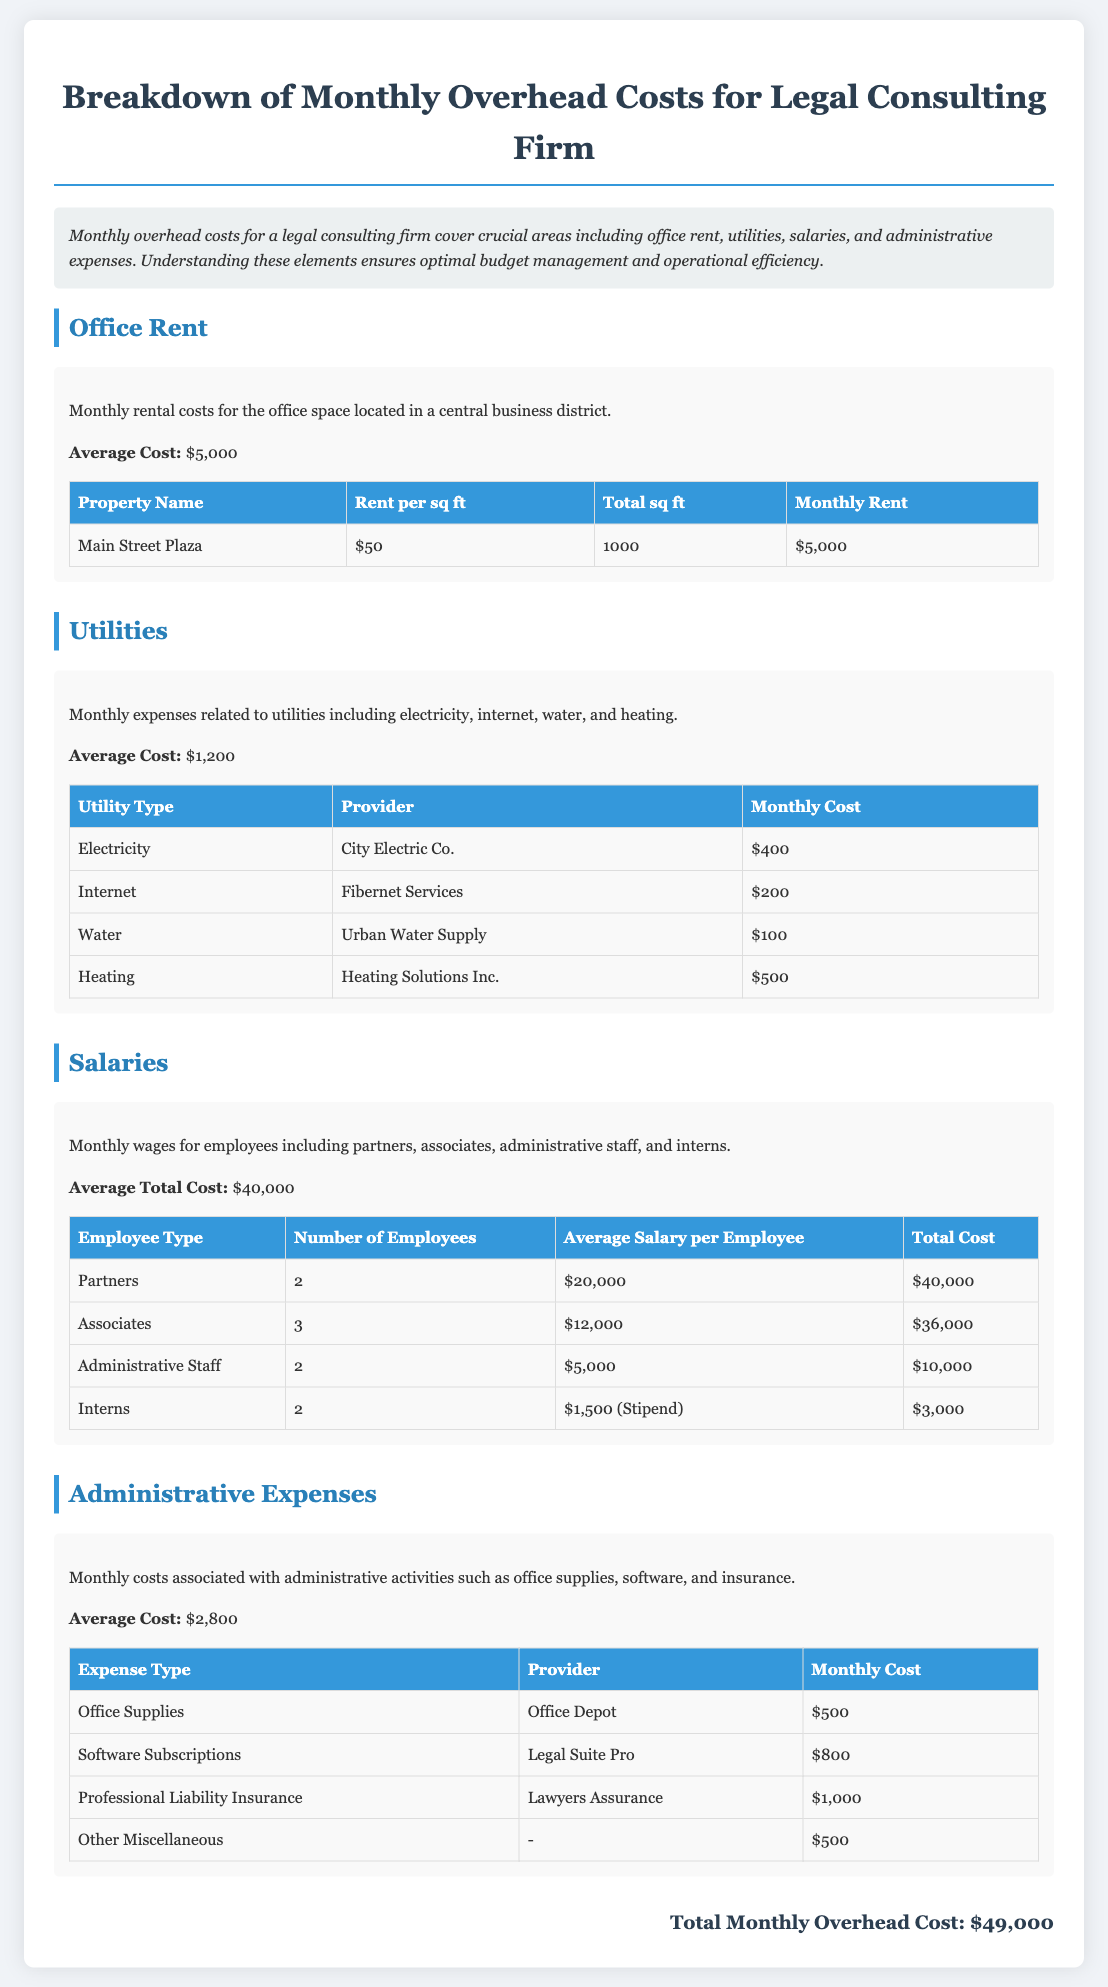What is the average cost of office rent? The average cost of office rent is directly stated in the Office Rent section as $5,000.
Answer: $5,000 How much do utilities cost on average per month? The document specifies the average cost of utilities in the Utilities section as $1,200.
Answer: $1,200 What is the total monthly cost for administrative expenses? The total monthly cost for administrative expenses is provided as $2,800 in the Administrative Expenses section.
Answer: $2,800 How many partners are there in the firm? The number of partners is listed in the Salaries section, which states there are 2 partners.
Answer: 2 What is the total monthly overhead cost for the firm? The total monthly overhead cost is the final figure mentioned in the document as $49,000.
Answer: $49,000 Which company provides internet service? The document lists Fibernet Services as the provider for internet in the Utilities section.
Answer: Fibernet Services How many interns are employed by the firm? The Salaries section indicates that there are 2 interns working at the firm.
Answer: 2 What is the monthly cost for professional liability insurance? The monthly cost for professional liability insurance is stated as $1,000 in the Administrative Expenses section.
Answer: $1,000 What is the average salary for associates? The average salary for associates, as detailed in the Salaries section, is $12,000 per employee.
Answer: $12,000 